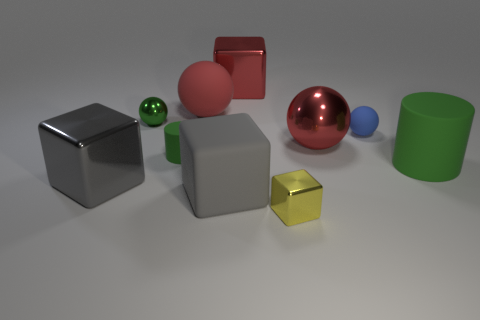Subtract all gray balls. Subtract all purple blocks. How many balls are left? 4 Subtract all cubes. How many objects are left? 6 Subtract all large red things. Subtract all yellow blocks. How many objects are left? 6 Add 9 large green matte things. How many large green matte things are left? 10 Add 3 tiny brown metallic objects. How many tiny brown metallic objects exist? 3 Subtract 0 purple cylinders. How many objects are left? 10 